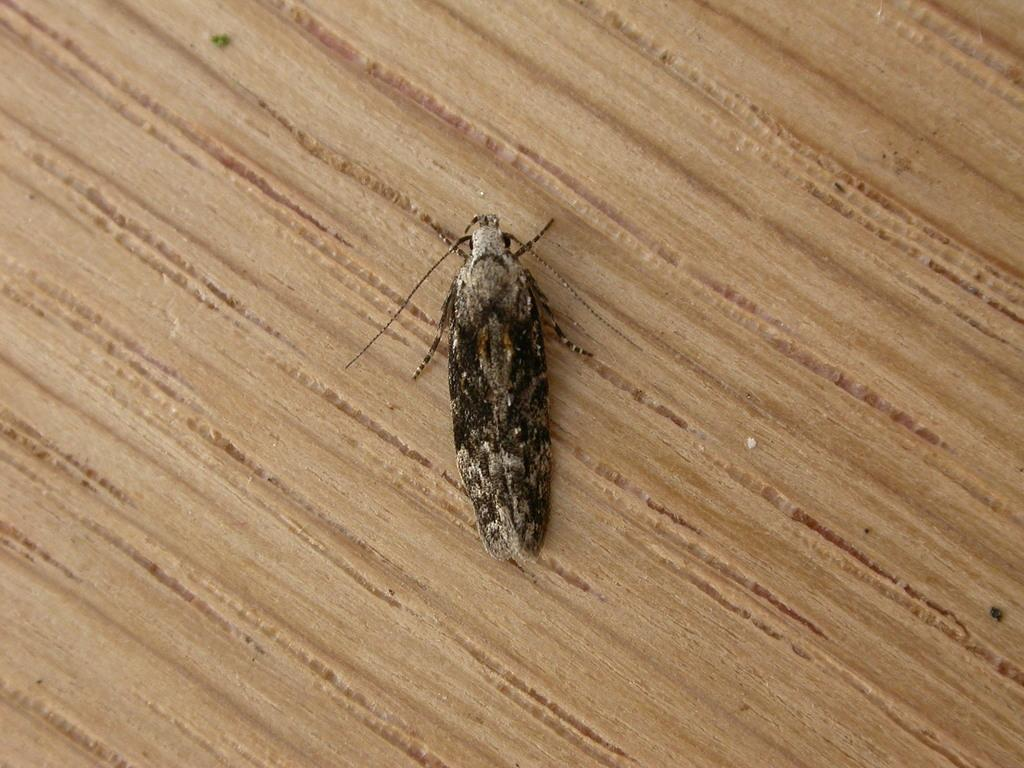What type of creature is present in the image? There is an insect in the image. What surface is the insect located on? The insect is on a wooden surface. What type of car can be seen in the image? There is no car present in the image; it only features an insect on a wooden surface. Can you tell me how many times the person in the image sneezes? There is no person present in the image, and therefore no sneezing can be observed. 